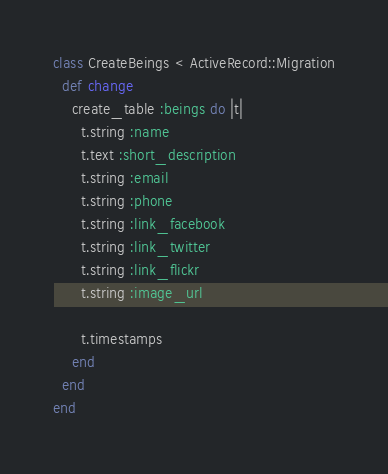Convert code to text. <code><loc_0><loc_0><loc_500><loc_500><_Ruby_>class CreateBeings < ActiveRecord::Migration
  def change
    create_table :beings do |t|
      t.string :name
      t.text :short_description
      t.string :email
      t.string :phone
      t.string :link_facebook
      t.string :link_twitter
      t.string :link_flickr
      t.string :image_url

      t.timestamps
    end
  end
end
</code> 